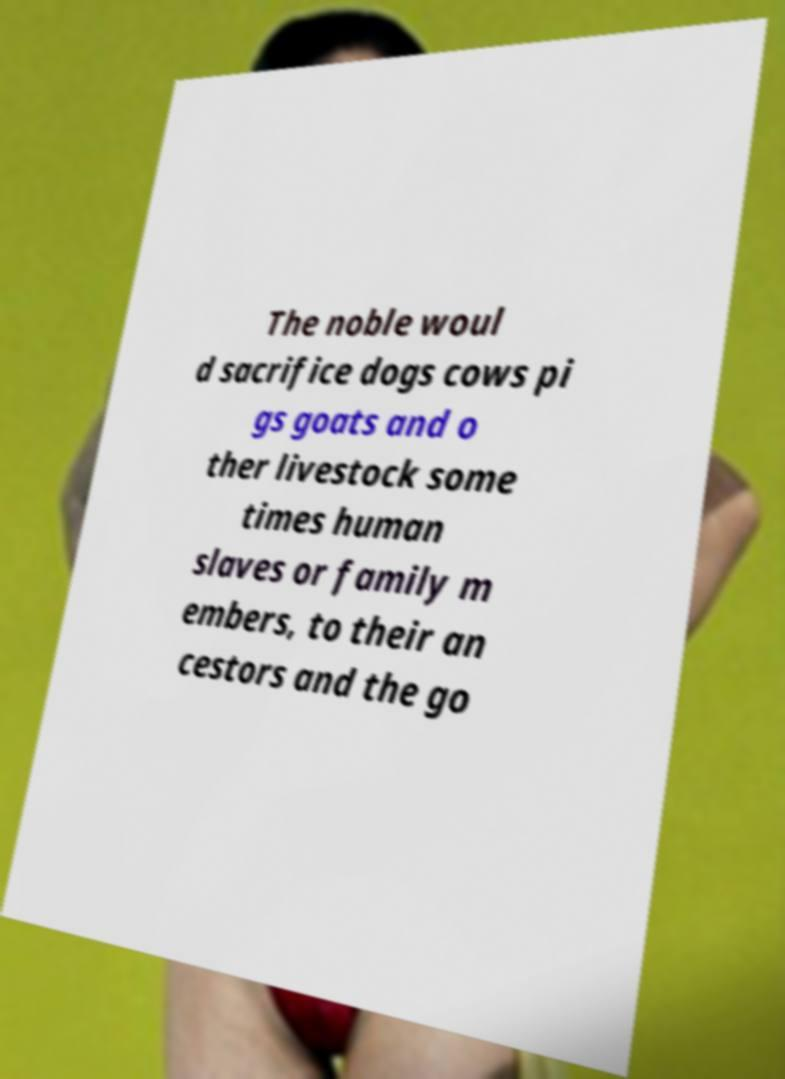Please read and relay the text visible in this image. What does it say? The noble woul d sacrifice dogs cows pi gs goats and o ther livestock some times human slaves or family m embers, to their an cestors and the go 